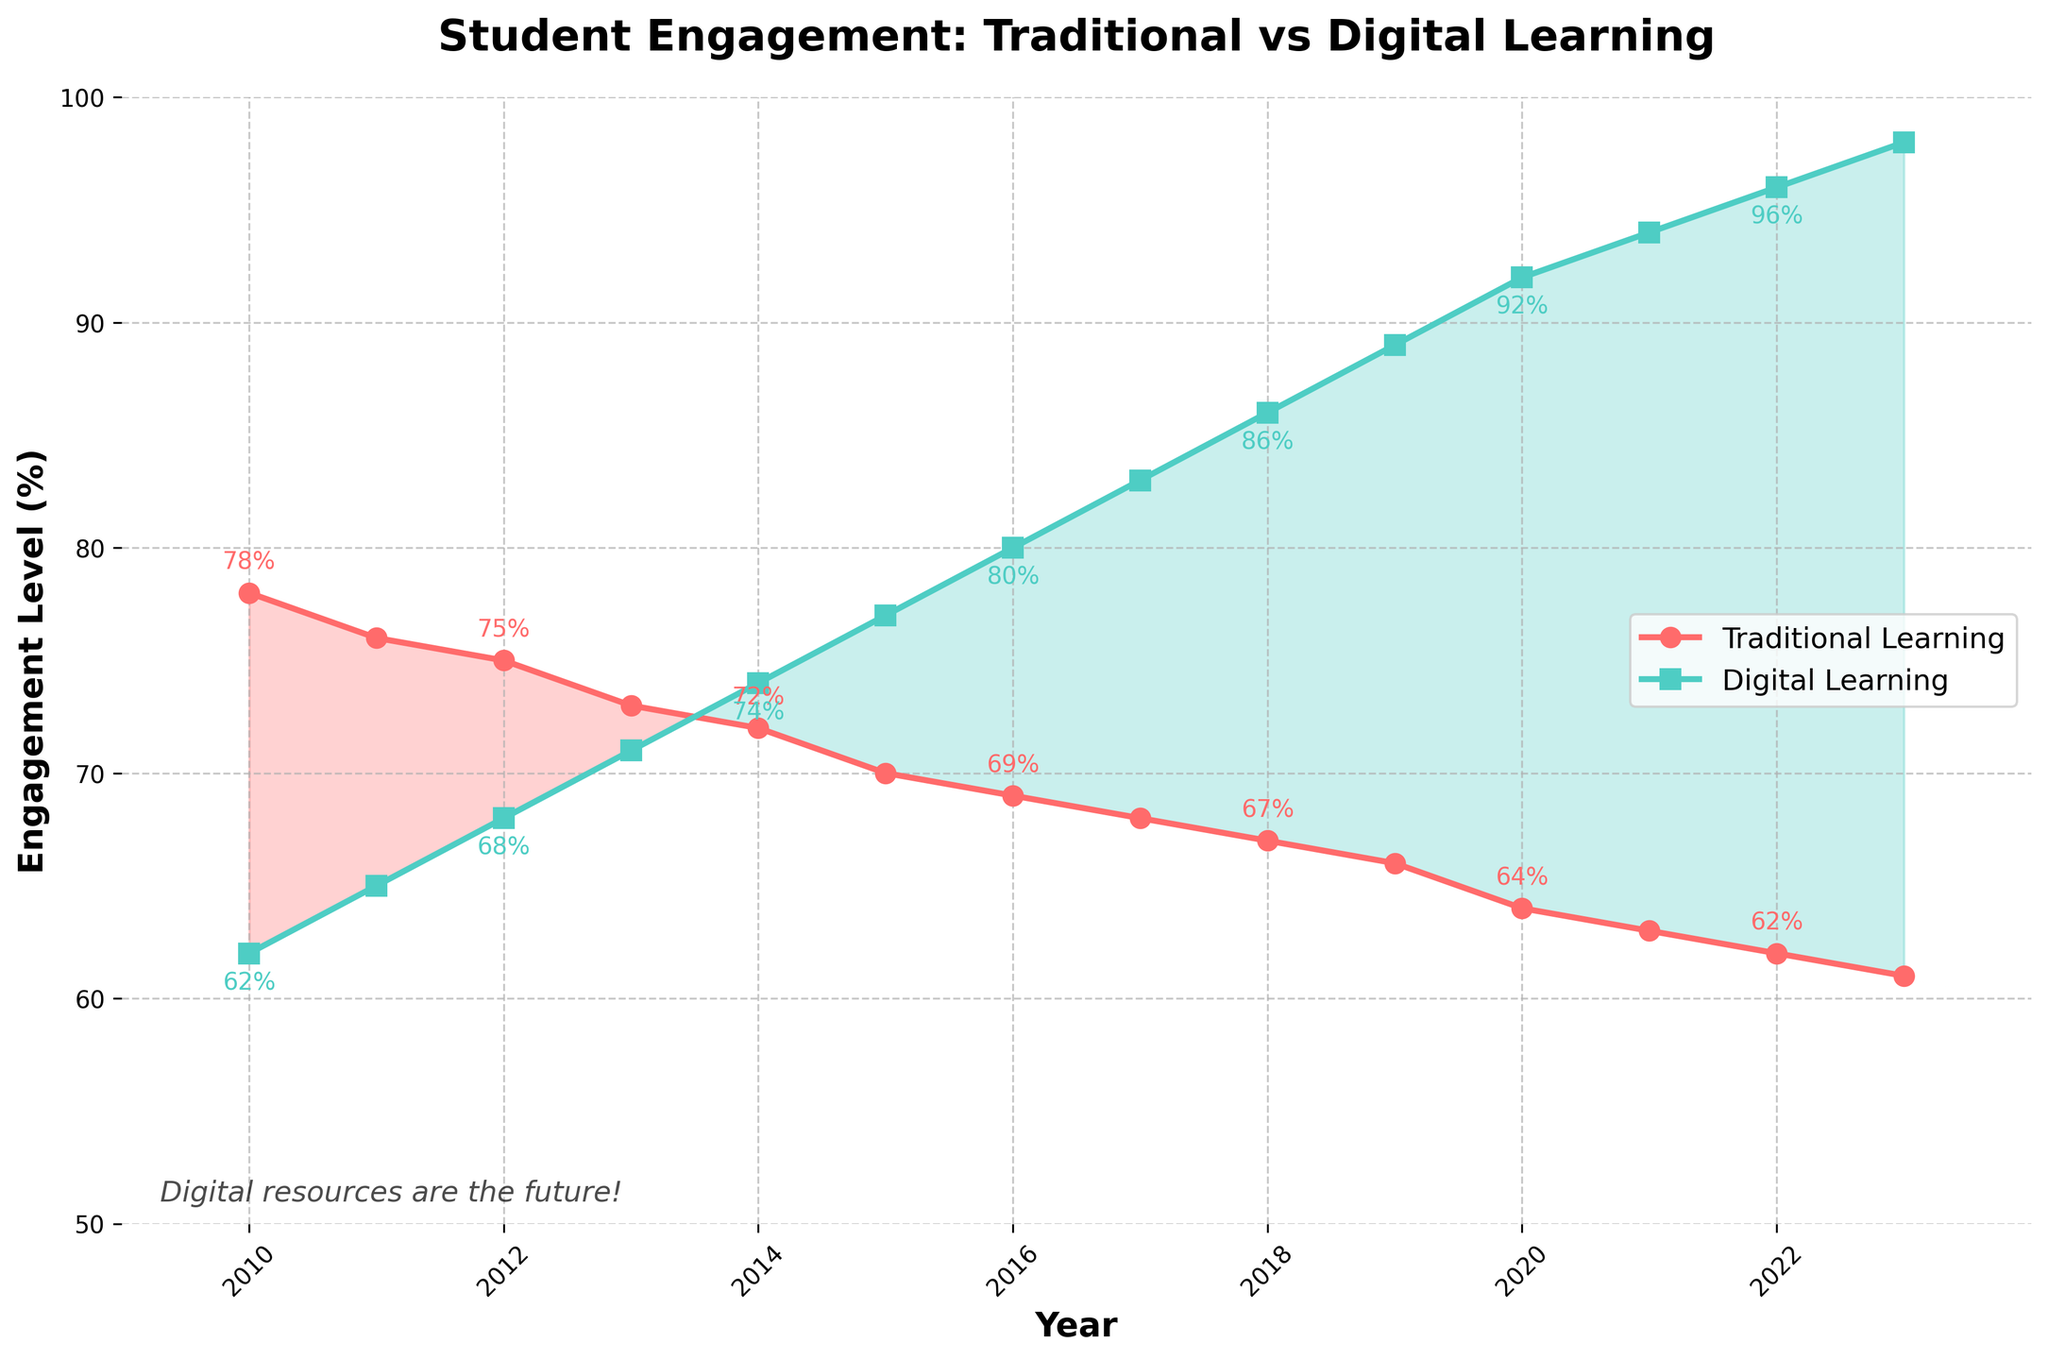What trend can you observe in the engagement levels for traditional learning from 2010 to 2023? The engagement level for traditional learning consistently decreases from 78% in 2010 to 61% in 2023.
Answer: Decreasing In what year did the engagement for digital learning surpass traditional learning? In 2014, the engagement level for digital learning (74%) surpassed traditional learning (72%).
Answer: 2014 What is the difference in engagement levels between digital and traditional learning in 2023? The engagement level for digital learning in 2023 is 98% and for traditional learning is 61%, so the difference is 98 - 61 = 37%.
Answer: 37% Which year shows the largest gap between digital and traditional learning engagement levels? In 2023, the engagement levels are 98% for digital and 61% for traditional, making the gap 37%, which is the largest over the years.
Answer: 2023 What's the average engagement level for traditional learning from 2010 to 2015? Sum the engagement levels from 2010 to 2015 (78 + 76 + 75 + 73 + 72 + 70) = 444, and divide by 6 years. So, 444 / 6 = 74%.
Answer: 74% How did the engagement of digital learning change from 2010 to 2017? The engagement level for digital learning increased from 62% in 2010 to 83% in 2017.
Answer: Increased Between which consecutive years did traditional learning engagement decrease the most? From 2019 to 2020, the engagement level for traditional learning decreased from 66% to 64%, a difference of 2%, the largest among consecutive years.
Answer: 2019-2020 During which years was the engagement for traditional learning higher than that of digital learning? From 2010 to 2013, traditional learning engagement was higher than that of digital learning.
Answer: 2010-2013 How many years show engagement levels of digital learning at 90% or above? From the data, the years 2020 (92%), 2021 (94%), 2022 (96%), and 2023 (98%) show engagement levels at 90% or above, totaling 4 years.
Answer: 4 Is there any year where the engagement level for both learning methods is equal? There is no year where the engagement levels for both learning methods are equal; digital learning gradually overtakes traditional learning.
Answer: No 